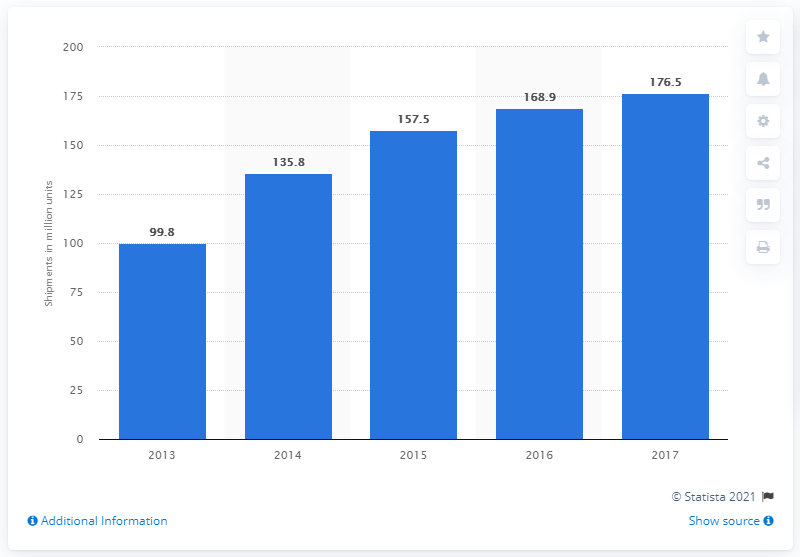Highlight a few significant elements in this photo. In 2017, a total of 176.5 smartphones were shipped in the Middle East and Africa. 